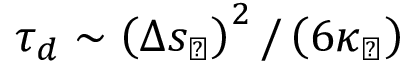<formula> <loc_0><loc_0><loc_500><loc_500>\tau _ { d } \sim \left ( \Delta s _ { \perp } \right ) ^ { 2 } / \left ( 6 \kappa _ { \perp } \right )</formula> 